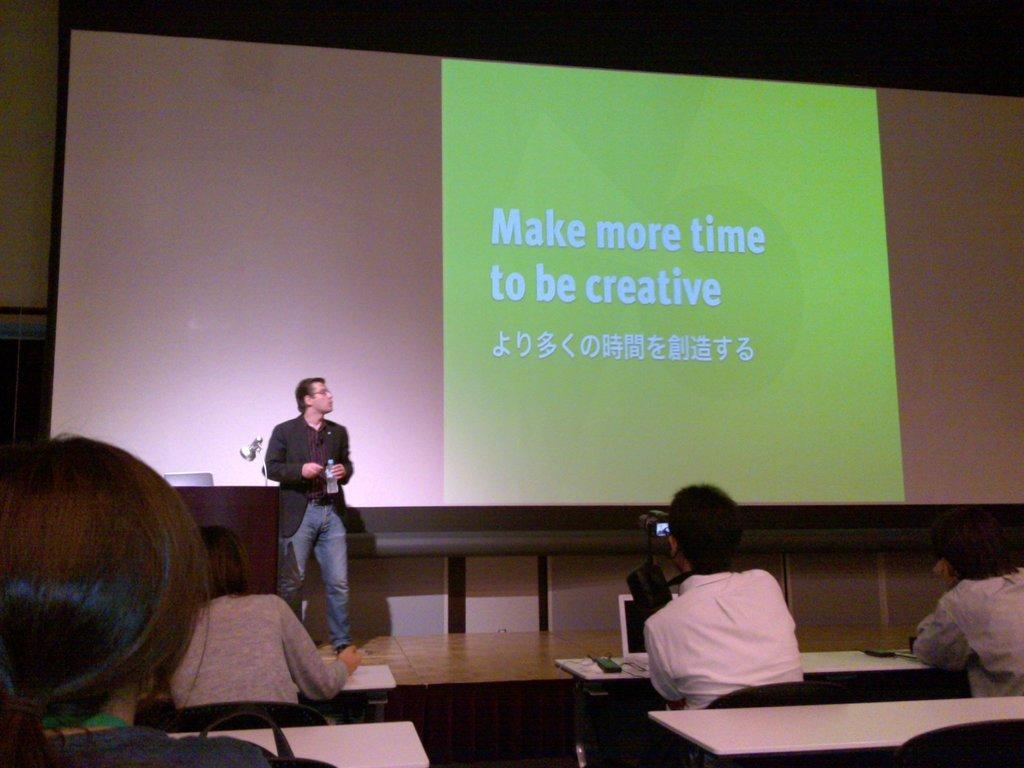<image>
Provide a brief description of the given image. Man giving a presentation with the screen saying Make more time to be creative. 